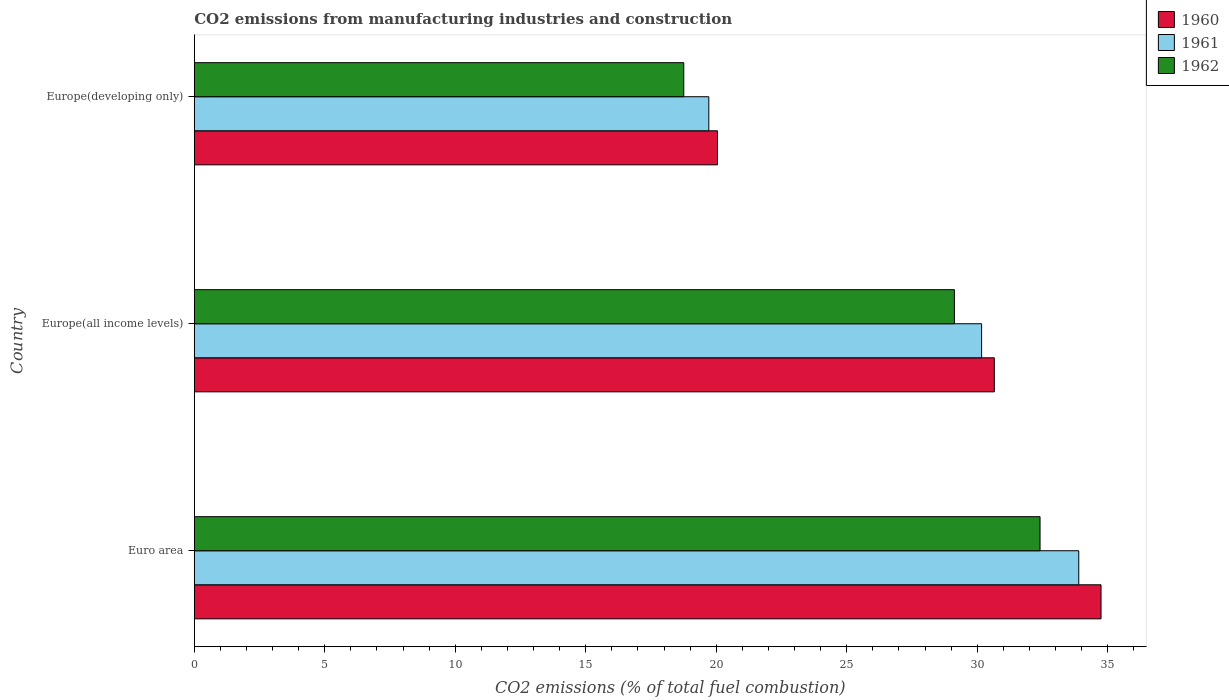How many different coloured bars are there?
Make the answer very short. 3. How many groups of bars are there?
Give a very brief answer. 3. Are the number of bars per tick equal to the number of legend labels?
Your response must be concise. Yes. Are the number of bars on each tick of the Y-axis equal?
Provide a short and direct response. Yes. How many bars are there on the 2nd tick from the top?
Your answer should be compact. 3. How many bars are there on the 1st tick from the bottom?
Make the answer very short. 3. What is the label of the 3rd group of bars from the top?
Keep it short and to the point. Euro area. In how many cases, is the number of bars for a given country not equal to the number of legend labels?
Your answer should be very brief. 0. What is the amount of CO2 emitted in 1962 in Europe(developing only)?
Offer a terse response. 18.76. Across all countries, what is the maximum amount of CO2 emitted in 1962?
Give a very brief answer. 32.41. Across all countries, what is the minimum amount of CO2 emitted in 1960?
Give a very brief answer. 20.05. In which country was the amount of CO2 emitted in 1962 maximum?
Provide a succinct answer. Euro area. In which country was the amount of CO2 emitted in 1961 minimum?
Your response must be concise. Europe(developing only). What is the total amount of CO2 emitted in 1960 in the graph?
Make the answer very short. 85.45. What is the difference between the amount of CO2 emitted in 1960 in Euro area and that in Europe(all income levels)?
Keep it short and to the point. 4.09. What is the difference between the amount of CO2 emitted in 1962 in Europe(developing only) and the amount of CO2 emitted in 1960 in Europe(all income levels)?
Your response must be concise. -11.9. What is the average amount of CO2 emitted in 1962 per country?
Provide a succinct answer. 26.76. What is the difference between the amount of CO2 emitted in 1962 and amount of CO2 emitted in 1961 in Europe(all income levels)?
Make the answer very short. -1.04. In how many countries, is the amount of CO2 emitted in 1962 greater than 22 %?
Your answer should be compact. 2. What is the ratio of the amount of CO2 emitted in 1961 in Euro area to that in Europe(all income levels)?
Your answer should be very brief. 1.12. Is the difference between the amount of CO2 emitted in 1962 in Euro area and Europe(developing only) greater than the difference between the amount of CO2 emitted in 1961 in Euro area and Europe(developing only)?
Keep it short and to the point. No. What is the difference between the highest and the second highest amount of CO2 emitted in 1962?
Make the answer very short. 3.28. What is the difference between the highest and the lowest amount of CO2 emitted in 1962?
Keep it short and to the point. 13.65. Is the sum of the amount of CO2 emitted in 1960 in Euro area and Europe(developing only) greater than the maximum amount of CO2 emitted in 1962 across all countries?
Your answer should be compact. Yes. What does the 1st bar from the bottom in Euro area represents?
Give a very brief answer. 1960. Is it the case that in every country, the sum of the amount of CO2 emitted in 1960 and amount of CO2 emitted in 1961 is greater than the amount of CO2 emitted in 1962?
Your answer should be very brief. Yes. How many bars are there?
Keep it short and to the point. 9. What is the difference between two consecutive major ticks on the X-axis?
Give a very brief answer. 5. Are the values on the major ticks of X-axis written in scientific E-notation?
Provide a short and direct response. No. Does the graph contain grids?
Make the answer very short. No. How many legend labels are there?
Offer a very short reply. 3. How are the legend labels stacked?
Your answer should be very brief. Vertical. What is the title of the graph?
Provide a succinct answer. CO2 emissions from manufacturing industries and construction. Does "2009" appear as one of the legend labels in the graph?
Make the answer very short. No. What is the label or title of the X-axis?
Your answer should be very brief. CO2 emissions (% of total fuel combustion). What is the label or title of the Y-axis?
Your response must be concise. Country. What is the CO2 emissions (% of total fuel combustion) in 1960 in Euro area?
Your response must be concise. 34.75. What is the CO2 emissions (% of total fuel combustion) in 1961 in Euro area?
Your answer should be compact. 33.89. What is the CO2 emissions (% of total fuel combustion) in 1962 in Euro area?
Offer a terse response. 32.41. What is the CO2 emissions (% of total fuel combustion) in 1960 in Europe(all income levels)?
Your answer should be compact. 30.66. What is the CO2 emissions (% of total fuel combustion) in 1961 in Europe(all income levels)?
Give a very brief answer. 30.17. What is the CO2 emissions (% of total fuel combustion) in 1962 in Europe(all income levels)?
Provide a succinct answer. 29.13. What is the CO2 emissions (% of total fuel combustion) of 1960 in Europe(developing only)?
Your response must be concise. 20.05. What is the CO2 emissions (% of total fuel combustion) in 1961 in Europe(developing only)?
Ensure brevity in your answer.  19.72. What is the CO2 emissions (% of total fuel combustion) in 1962 in Europe(developing only)?
Make the answer very short. 18.76. Across all countries, what is the maximum CO2 emissions (% of total fuel combustion) in 1960?
Provide a succinct answer. 34.75. Across all countries, what is the maximum CO2 emissions (% of total fuel combustion) of 1961?
Your answer should be compact. 33.89. Across all countries, what is the maximum CO2 emissions (% of total fuel combustion) of 1962?
Make the answer very short. 32.41. Across all countries, what is the minimum CO2 emissions (% of total fuel combustion) of 1960?
Provide a short and direct response. 20.05. Across all countries, what is the minimum CO2 emissions (% of total fuel combustion) in 1961?
Offer a terse response. 19.72. Across all countries, what is the minimum CO2 emissions (% of total fuel combustion) of 1962?
Offer a very short reply. 18.76. What is the total CO2 emissions (% of total fuel combustion) of 1960 in the graph?
Ensure brevity in your answer.  85.45. What is the total CO2 emissions (% of total fuel combustion) in 1961 in the graph?
Offer a terse response. 83.78. What is the total CO2 emissions (% of total fuel combustion) of 1962 in the graph?
Give a very brief answer. 80.29. What is the difference between the CO2 emissions (% of total fuel combustion) in 1960 in Euro area and that in Europe(all income levels)?
Give a very brief answer. 4.09. What is the difference between the CO2 emissions (% of total fuel combustion) of 1961 in Euro area and that in Europe(all income levels)?
Give a very brief answer. 3.72. What is the difference between the CO2 emissions (% of total fuel combustion) in 1962 in Euro area and that in Europe(all income levels)?
Provide a short and direct response. 3.28. What is the difference between the CO2 emissions (% of total fuel combustion) of 1960 in Euro area and that in Europe(developing only)?
Your answer should be very brief. 14.7. What is the difference between the CO2 emissions (% of total fuel combustion) of 1961 in Euro area and that in Europe(developing only)?
Make the answer very short. 14.18. What is the difference between the CO2 emissions (% of total fuel combustion) of 1962 in Euro area and that in Europe(developing only)?
Offer a very short reply. 13.65. What is the difference between the CO2 emissions (% of total fuel combustion) of 1960 in Europe(all income levels) and that in Europe(developing only)?
Offer a terse response. 10.61. What is the difference between the CO2 emissions (% of total fuel combustion) of 1961 in Europe(all income levels) and that in Europe(developing only)?
Offer a very short reply. 10.45. What is the difference between the CO2 emissions (% of total fuel combustion) of 1962 in Europe(all income levels) and that in Europe(developing only)?
Your response must be concise. 10.37. What is the difference between the CO2 emissions (% of total fuel combustion) in 1960 in Euro area and the CO2 emissions (% of total fuel combustion) in 1961 in Europe(all income levels)?
Keep it short and to the point. 4.58. What is the difference between the CO2 emissions (% of total fuel combustion) in 1960 in Euro area and the CO2 emissions (% of total fuel combustion) in 1962 in Europe(all income levels)?
Ensure brevity in your answer.  5.62. What is the difference between the CO2 emissions (% of total fuel combustion) of 1961 in Euro area and the CO2 emissions (% of total fuel combustion) of 1962 in Europe(all income levels)?
Give a very brief answer. 4.77. What is the difference between the CO2 emissions (% of total fuel combustion) of 1960 in Euro area and the CO2 emissions (% of total fuel combustion) of 1961 in Europe(developing only)?
Make the answer very short. 15.03. What is the difference between the CO2 emissions (% of total fuel combustion) of 1960 in Euro area and the CO2 emissions (% of total fuel combustion) of 1962 in Europe(developing only)?
Ensure brevity in your answer.  15.99. What is the difference between the CO2 emissions (% of total fuel combustion) of 1961 in Euro area and the CO2 emissions (% of total fuel combustion) of 1962 in Europe(developing only)?
Your response must be concise. 15.14. What is the difference between the CO2 emissions (% of total fuel combustion) in 1960 in Europe(all income levels) and the CO2 emissions (% of total fuel combustion) in 1961 in Europe(developing only)?
Your answer should be very brief. 10.94. What is the difference between the CO2 emissions (% of total fuel combustion) of 1960 in Europe(all income levels) and the CO2 emissions (% of total fuel combustion) of 1962 in Europe(developing only)?
Give a very brief answer. 11.9. What is the difference between the CO2 emissions (% of total fuel combustion) in 1961 in Europe(all income levels) and the CO2 emissions (% of total fuel combustion) in 1962 in Europe(developing only)?
Offer a terse response. 11.41. What is the average CO2 emissions (% of total fuel combustion) in 1960 per country?
Keep it short and to the point. 28.48. What is the average CO2 emissions (% of total fuel combustion) of 1961 per country?
Ensure brevity in your answer.  27.93. What is the average CO2 emissions (% of total fuel combustion) of 1962 per country?
Provide a short and direct response. 26.76. What is the difference between the CO2 emissions (% of total fuel combustion) in 1960 and CO2 emissions (% of total fuel combustion) in 1961 in Euro area?
Provide a short and direct response. 0.85. What is the difference between the CO2 emissions (% of total fuel combustion) in 1960 and CO2 emissions (% of total fuel combustion) in 1962 in Euro area?
Provide a short and direct response. 2.34. What is the difference between the CO2 emissions (% of total fuel combustion) in 1961 and CO2 emissions (% of total fuel combustion) in 1962 in Euro area?
Offer a very short reply. 1.48. What is the difference between the CO2 emissions (% of total fuel combustion) of 1960 and CO2 emissions (% of total fuel combustion) of 1961 in Europe(all income levels)?
Offer a terse response. 0.49. What is the difference between the CO2 emissions (% of total fuel combustion) in 1960 and CO2 emissions (% of total fuel combustion) in 1962 in Europe(all income levels)?
Your response must be concise. 1.53. What is the difference between the CO2 emissions (% of total fuel combustion) of 1961 and CO2 emissions (% of total fuel combustion) of 1962 in Europe(all income levels)?
Give a very brief answer. 1.04. What is the difference between the CO2 emissions (% of total fuel combustion) of 1960 and CO2 emissions (% of total fuel combustion) of 1961 in Europe(developing only)?
Offer a very short reply. 0.33. What is the difference between the CO2 emissions (% of total fuel combustion) of 1960 and CO2 emissions (% of total fuel combustion) of 1962 in Europe(developing only)?
Your response must be concise. 1.29. What is the difference between the CO2 emissions (% of total fuel combustion) of 1961 and CO2 emissions (% of total fuel combustion) of 1962 in Europe(developing only)?
Offer a very short reply. 0.96. What is the ratio of the CO2 emissions (% of total fuel combustion) in 1960 in Euro area to that in Europe(all income levels)?
Ensure brevity in your answer.  1.13. What is the ratio of the CO2 emissions (% of total fuel combustion) of 1961 in Euro area to that in Europe(all income levels)?
Ensure brevity in your answer.  1.12. What is the ratio of the CO2 emissions (% of total fuel combustion) of 1962 in Euro area to that in Europe(all income levels)?
Give a very brief answer. 1.11. What is the ratio of the CO2 emissions (% of total fuel combustion) of 1960 in Euro area to that in Europe(developing only)?
Provide a succinct answer. 1.73. What is the ratio of the CO2 emissions (% of total fuel combustion) in 1961 in Euro area to that in Europe(developing only)?
Give a very brief answer. 1.72. What is the ratio of the CO2 emissions (% of total fuel combustion) of 1962 in Euro area to that in Europe(developing only)?
Make the answer very short. 1.73. What is the ratio of the CO2 emissions (% of total fuel combustion) of 1960 in Europe(all income levels) to that in Europe(developing only)?
Provide a short and direct response. 1.53. What is the ratio of the CO2 emissions (% of total fuel combustion) of 1961 in Europe(all income levels) to that in Europe(developing only)?
Offer a very short reply. 1.53. What is the ratio of the CO2 emissions (% of total fuel combustion) of 1962 in Europe(all income levels) to that in Europe(developing only)?
Ensure brevity in your answer.  1.55. What is the difference between the highest and the second highest CO2 emissions (% of total fuel combustion) of 1960?
Keep it short and to the point. 4.09. What is the difference between the highest and the second highest CO2 emissions (% of total fuel combustion) in 1961?
Make the answer very short. 3.72. What is the difference between the highest and the second highest CO2 emissions (% of total fuel combustion) of 1962?
Offer a terse response. 3.28. What is the difference between the highest and the lowest CO2 emissions (% of total fuel combustion) in 1960?
Offer a very short reply. 14.7. What is the difference between the highest and the lowest CO2 emissions (% of total fuel combustion) in 1961?
Offer a very short reply. 14.18. What is the difference between the highest and the lowest CO2 emissions (% of total fuel combustion) in 1962?
Make the answer very short. 13.65. 